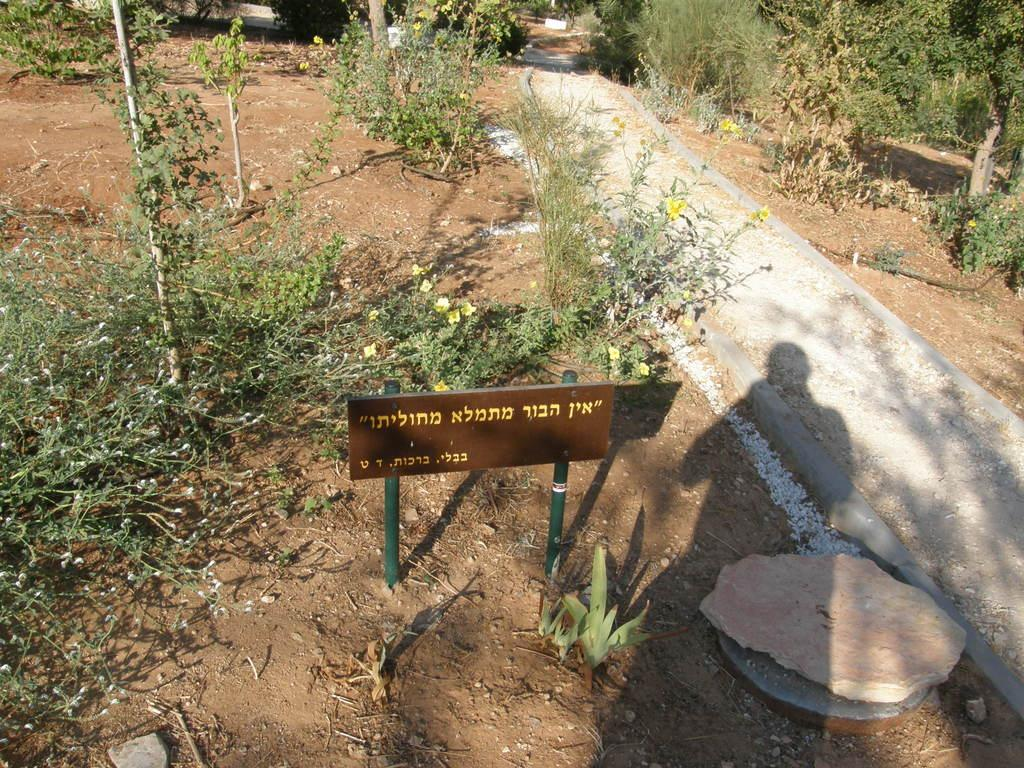What is the main object in the image? There is a board on a pole in the image. What can be seen in the background of the image? There are trees and plants in the background of the image. Where is the manhole located in the image? The manhole is on the right side of the image. What type of game is being played on the board in the image? There is no game being played on the board in the image; it is just a board on a pole. What sound does the alarm make in the image? There is no alarm present in the image. 